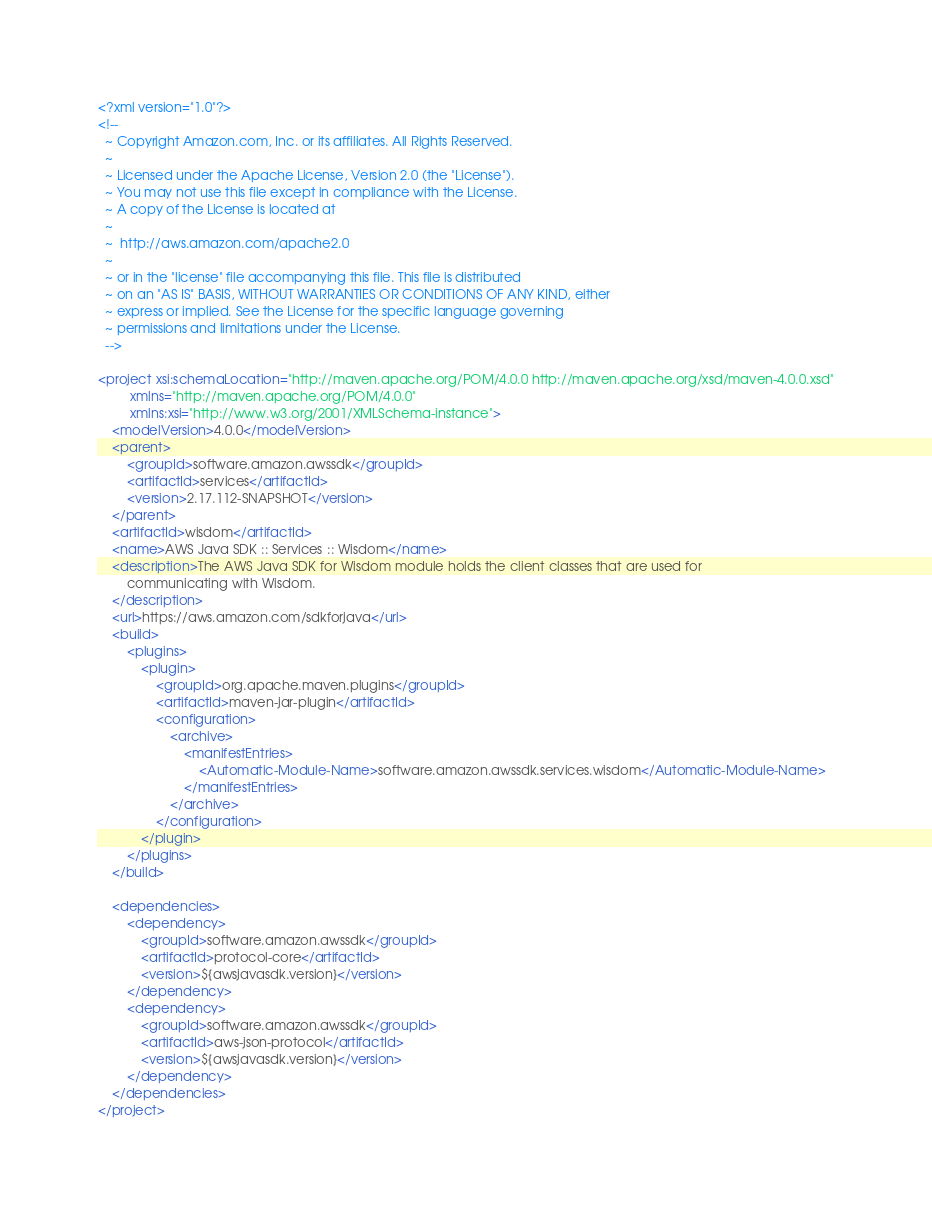<code> <loc_0><loc_0><loc_500><loc_500><_XML_><?xml version="1.0"?>
<!--
  ~ Copyright Amazon.com, Inc. or its affiliates. All Rights Reserved.
  ~
  ~ Licensed under the Apache License, Version 2.0 (the "License").
  ~ You may not use this file except in compliance with the License.
  ~ A copy of the License is located at
  ~
  ~  http://aws.amazon.com/apache2.0
  ~
  ~ or in the "license" file accompanying this file. This file is distributed
  ~ on an "AS IS" BASIS, WITHOUT WARRANTIES OR CONDITIONS OF ANY KIND, either
  ~ express or implied. See the License for the specific language governing
  ~ permissions and limitations under the License.
  -->

<project xsi:schemaLocation="http://maven.apache.org/POM/4.0.0 http://maven.apache.org/xsd/maven-4.0.0.xsd"
         xmlns="http://maven.apache.org/POM/4.0.0"
         xmlns:xsi="http://www.w3.org/2001/XMLSchema-instance">
    <modelVersion>4.0.0</modelVersion>
    <parent>
        <groupId>software.amazon.awssdk</groupId>
        <artifactId>services</artifactId>
        <version>2.17.112-SNAPSHOT</version>
    </parent>
    <artifactId>wisdom</artifactId>
    <name>AWS Java SDK :: Services :: Wisdom</name>
    <description>The AWS Java SDK for Wisdom module holds the client classes that are used for
        communicating with Wisdom.
    </description>
    <url>https://aws.amazon.com/sdkforjava</url>
    <build>
        <plugins>
            <plugin>
                <groupId>org.apache.maven.plugins</groupId>
                <artifactId>maven-jar-plugin</artifactId>
                <configuration>
                    <archive>
                        <manifestEntries>
                            <Automatic-Module-Name>software.amazon.awssdk.services.wisdom</Automatic-Module-Name>
                        </manifestEntries>
                    </archive>
                </configuration>
            </plugin>
        </plugins>
    </build>

    <dependencies>
        <dependency>
            <groupId>software.amazon.awssdk</groupId>
            <artifactId>protocol-core</artifactId>
            <version>${awsjavasdk.version}</version>
        </dependency>
        <dependency>
            <groupId>software.amazon.awssdk</groupId>
            <artifactId>aws-json-protocol</artifactId>
            <version>${awsjavasdk.version}</version>
        </dependency>
    </dependencies>
</project>
</code> 